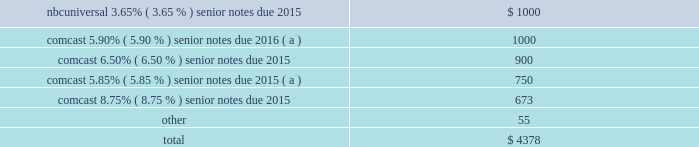Comcast corporation 2015 debt redemptions and repayments year ended december 31 , 2015 ( in millions ) .
( a ) the early redemption of these senior notes resulted in $ 47 million of additional interest expense in 2015 .
Debt instruments revolving credit facilities as of december 31 , 2015 , comcast and comcast cable communications , llc had a $ 6.25 billion revolving credit facility due june 2017 with a syndicate of banks ( 201ccomcast revolving credit facility 201d ) .
The interest rate on this facility consists of a base rate plus a borrowing margin that is determined based on our credit rating .
As of december 31 , 2015 , the borrowing margin for london interbank offered rate ( 201clibor 201d ) based borrow- ings was 1.00% ( 1.00 % ) .
This revolving credit facility requires that we maintain certain financial ratios based on our debt and our operating income before depreciation and amortization , as defined in the credit facility .
We were in compliance with all financial covenants for all periods presented .
As of december 31 , 2015 , nbcuniversal enterprise had a $ 1.35 billion revolving credit facility due march 2018 with a syndicate of banks ( 201cnbcuniversal enterprise revolving credit facility 201d ) .
The interest rate on this facility consists of a base rate plus a borrowing margin that is determined based on our credit rating .
As of december 31 , 2015 , the borrowing margin for libor-based borrowings was 1.00% ( 1.00 % ) .
As of december 31 , 2015 , amounts available under our consolidated credit facilities , net of amounts out- standing under our commercial paper programs and outstanding letters of credit , totaled $ 6.4 billion , which included $ 775 million available under the nbcuniversal enterprise revolving credit facility .
Term loans as a result of the universal studios japan transaction , we consolidated a5400 billion of term loans having a final maturity of november 2020 .
In accordance with acquisition accounting , these debt securities were recorded at fair value as of the acquisition date .
These term loans contain financial and operating covenants and are secured by the assets of universal studios japan and the equity interests of the investors .
We do not guarantee these term loans and they are otherwise nonrecourse to us .
Commercial paper programs our commercial paper programs provide a lower-cost source of borrowing to fund our short-term working capital requirements .
The maximum borrowing capacity under the comcast commercial paper program is $ 6.25 billion and it is supported by the comcast revolving credit facility .
The maximum borrowing capacity under the nbcuniversal enterprise commercial paper program is $ 1.35 billion and it is supported by the nbcuniversal enterprise revolving credit facility .
Letters of credit as of december 31 , 2015 , we and certain of our subsidiaries had unused irrevocable standby letters of credit totaling $ 464 million to cover potential fundings under various agreements .
99 comcast 2015 annual report on form 10-k .
What was the percent of the net of amounts out- standing under our commercial paper programs and outstanding letters of credit associated with the nbcuniversal enterprise revolving credit facility? 
Computations: (775 / 6.4)
Answer: 121.09375. 